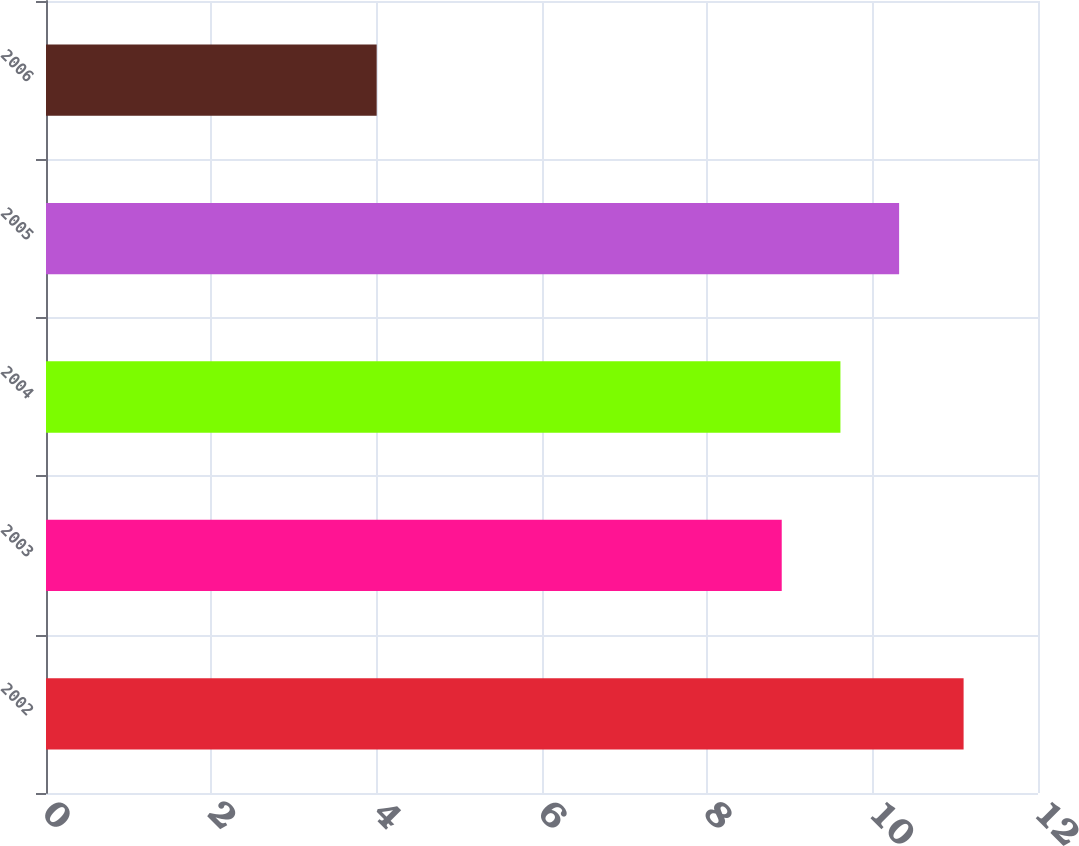Convert chart. <chart><loc_0><loc_0><loc_500><loc_500><bar_chart><fcel>2002<fcel>2003<fcel>2004<fcel>2005<fcel>2006<nl><fcel>11.1<fcel>8.9<fcel>9.61<fcel>10.32<fcel>4<nl></chart> 